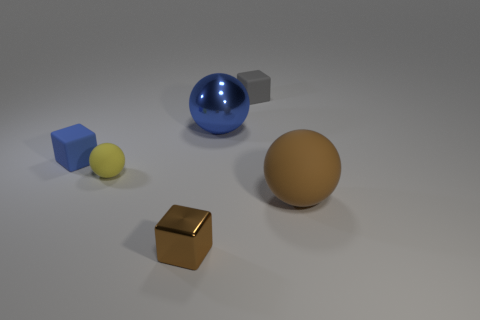Add 4 big cyan matte cubes. How many objects exist? 10 Subtract 1 blue blocks. How many objects are left? 5 Subtract all cubes. Subtract all yellow rubber objects. How many objects are left? 2 Add 5 blue shiny objects. How many blue shiny objects are left? 6 Add 5 small green matte things. How many small green matte things exist? 5 